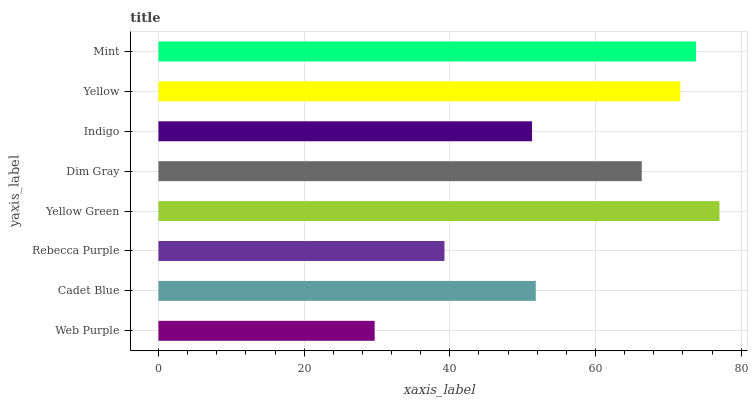Is Web Purple the minimum?
Answer yes or no. Yes. Is Yellow Green the maximum?
Answer yes or no. Yes. Is Cadet Blue the minimum?
Answer yes or no. No. Is Cadet Blue the maximum?
Answer yes or no. No. Is Cadet Blue greater than Web Purple?
Answer yes or no. Yes. Is Web Purple less than Cadet Blue?
Answer yes or no. Yes. Is Web Purple greater than Cadet Blue?
Answer yes or no. No. Is Cadet Blue less than Web Purple?
Answer yes or no. No. Is Dim Gray the high median?
Answer yes or no. Yes. Is Cadet Blue the low median?
Answer yes or no. Yes. Is Web Purple the high median?
Answer yes or no. No. Is Yellow the low median?
Answer yes or no. No. 